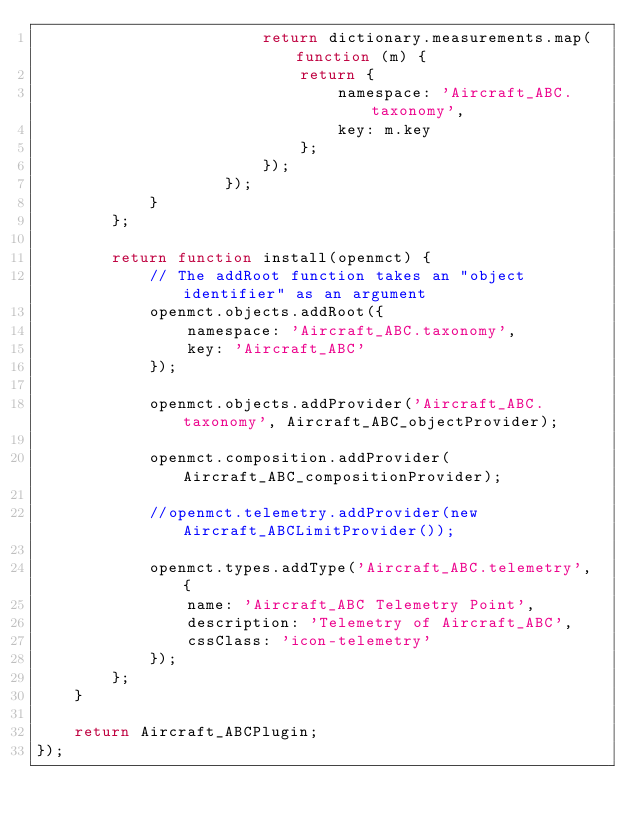Convert code to text. <code><loc_0><loc_0><loc_500><loc_500><_JavaScript_>                        return dictionary.measurements.map(function (m) {
                            return {
                                namespace: 'Aircraft_ABC.taxonomy',
                                key: m.key
                            };
                        });
                    });
            }
        };

        return function install(openmct) {
            // The addRoot function takes an "object identifier" as an argument
            openmct.objects.addRoot({
                namespace: 'Aircraft_ABC.taxonomy',
                key: 'Aircraft_ABC'
            });

            openmct.objects.addProvider('Aircraft_ABC.taxonomy', Aircraft_ABC_objectProvider);

            openmct.composition.addProvider(Aircraft_ABC_compositionProvider);

            //openmct.telemetry.addProvider(new Aircraft_ABCLimitProvider());

            openmct.types.addType('Aircraft_ABC.telemetry', {
                name: 'Aircraft_ABC Telemetry Point',
                description: 'Telemetry of Aircraft_ABC',
                cssClass: 'icon-telemetry'
            });
        };
    }

    return Aircraft_ABCPlugin;
});
</code> 